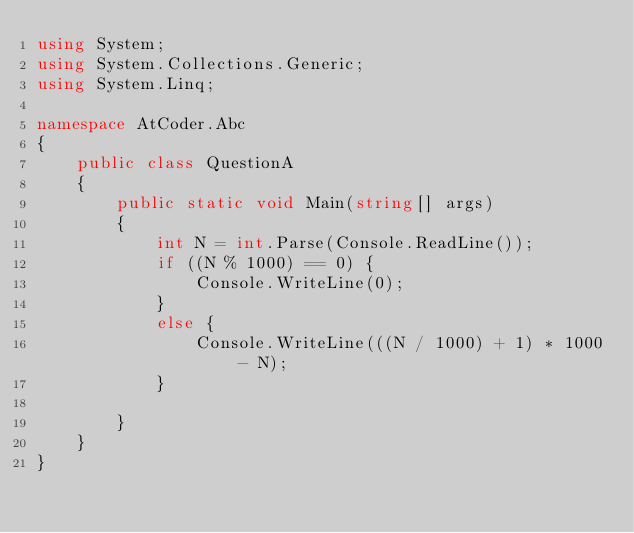<code> <loc_0><loc_0><loc_500><loc_500><_C#_>using System;
using System.Collections.Generic;
using System.Linq;

namespace AtCoder.Abc
{
    public class QuestionA
    {
        public static void Main(string[] args)
        {
            int N = int.Parse(Console.ReadLine());
            if ((N % 1000) == 0) {
                Console.WriteLine(0);
            } 
            else {
                Console.WriteLine(((N / 1000) + 1) * 1000 - N);
            }
            
        }
    }
}
</code> 